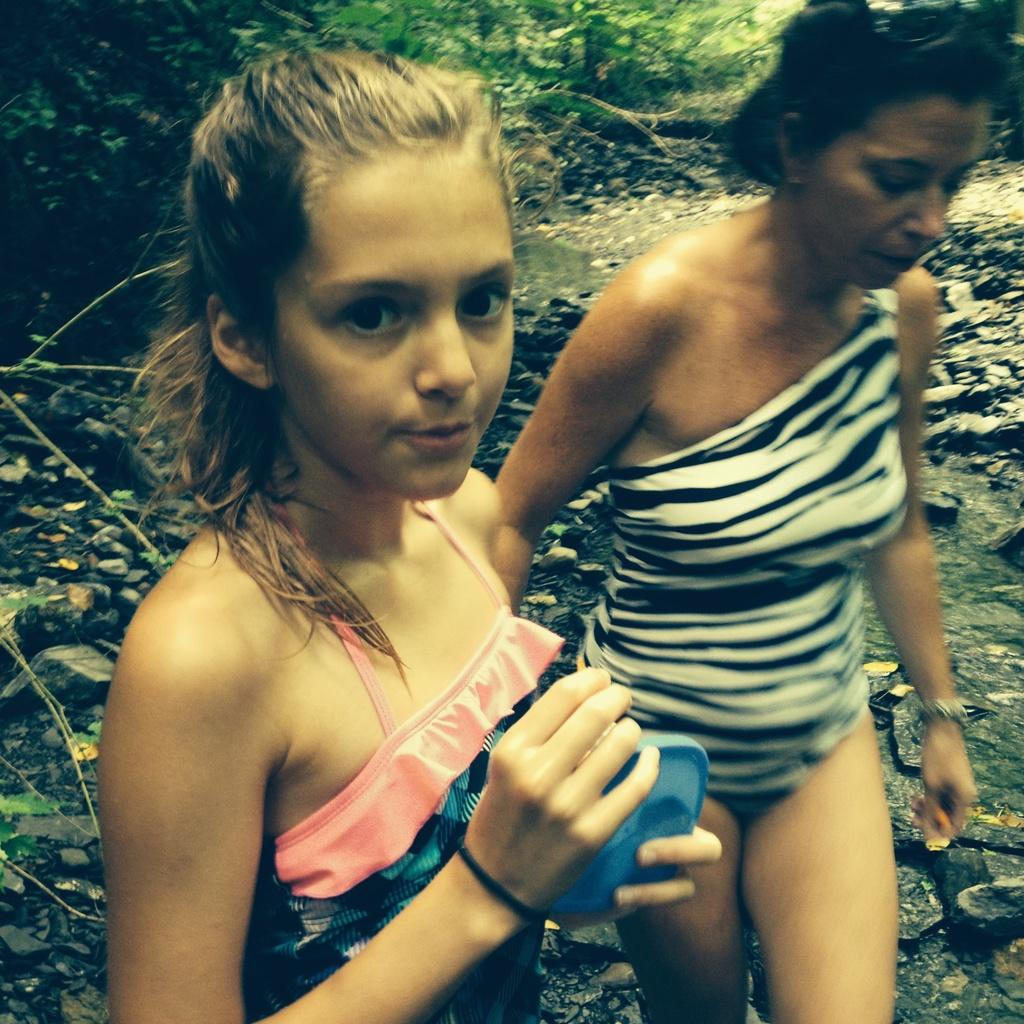How many persons are in the image? There are two persons in the image. What can be seen in the background of the image? There are stones, water, and trees visible in the background of the image. What type of tail can be seen on the tomatoes in the image? There are no tomatoes present in the image, and therefore no tails can be observed. What substance is being used by the persons in the image? The provided facts do not mention any specific substance being used by the persons in the image. 